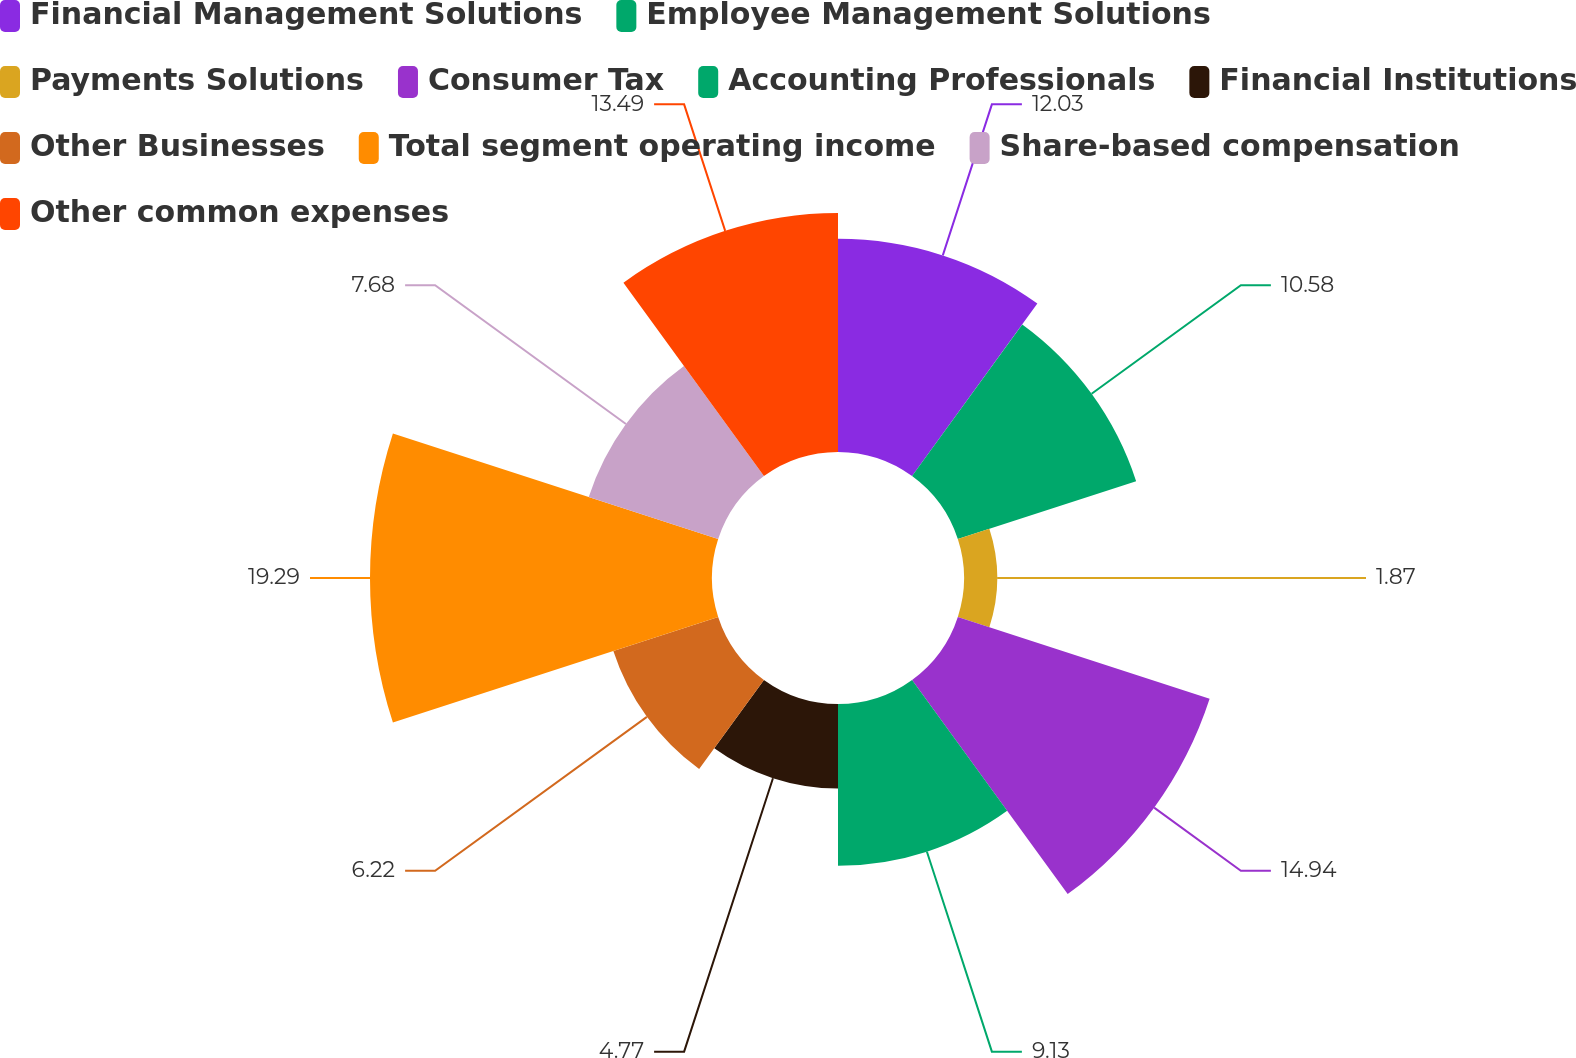Convert chart. <chart><loc_0><loc_0><loc_500><loc_500><pie_chart><fcel>Financial Management Solutions<fcel>Employee Management Solutions<fcel>Payments Solutions<fcel>Consumer Tax<fcel>Accounting Professionals<fcel>Financial Institutions<fcel>Other Businesses<fcel>Total segment operating income<fcel>Share-based compensation<fcel>Other common expenses<nl><fcel>12.03%<fcel>10.58%<fcel>1.87%<fcel>14.94%<fcel>9.13%<fcel>4.77%<fcel>6.22%<fcel>19.3%<fcel>7.68%<fcel>13.49%<nl></chart> 